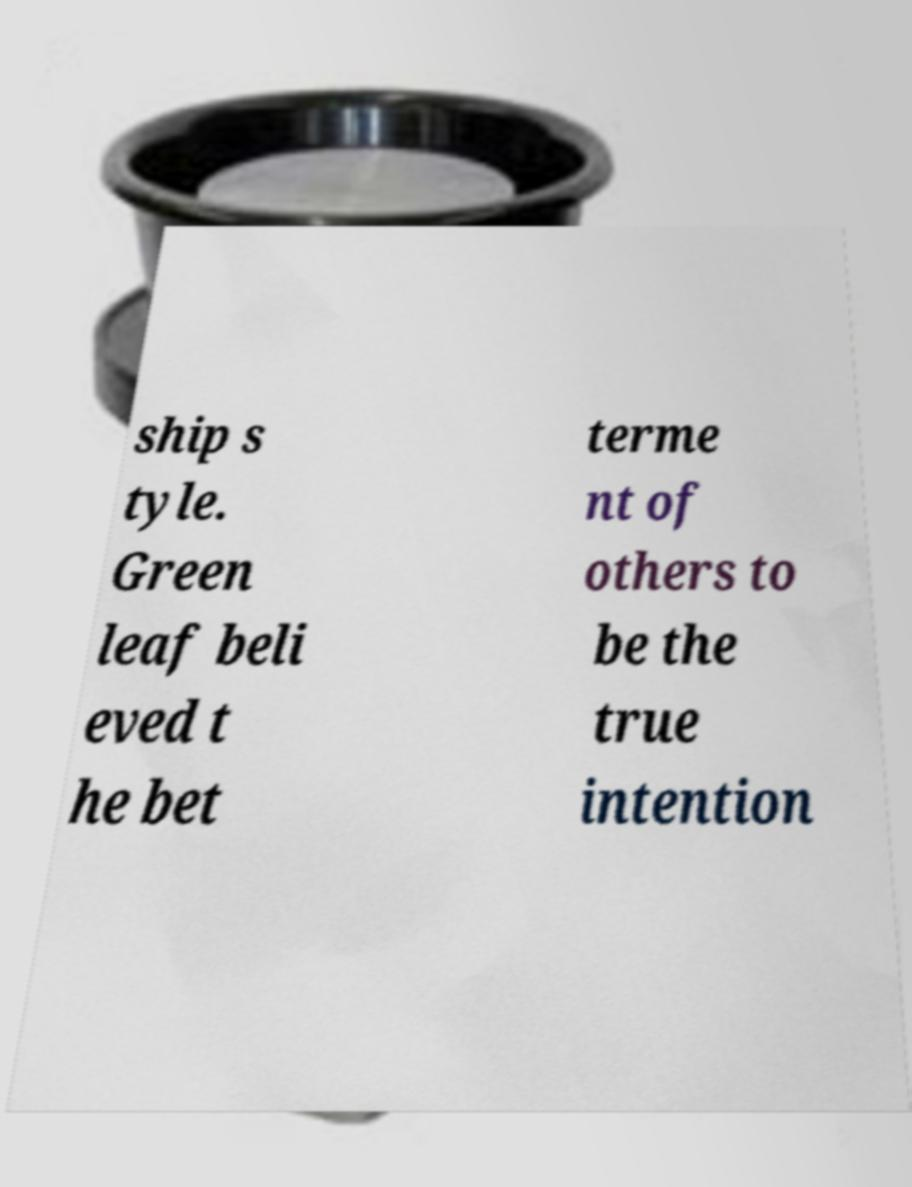For documentation purposes, I need the text within this image transcribed. Could you provide that? ship s tyle. Green leaf beli eved t he bet terme nt of others to be the true intention 